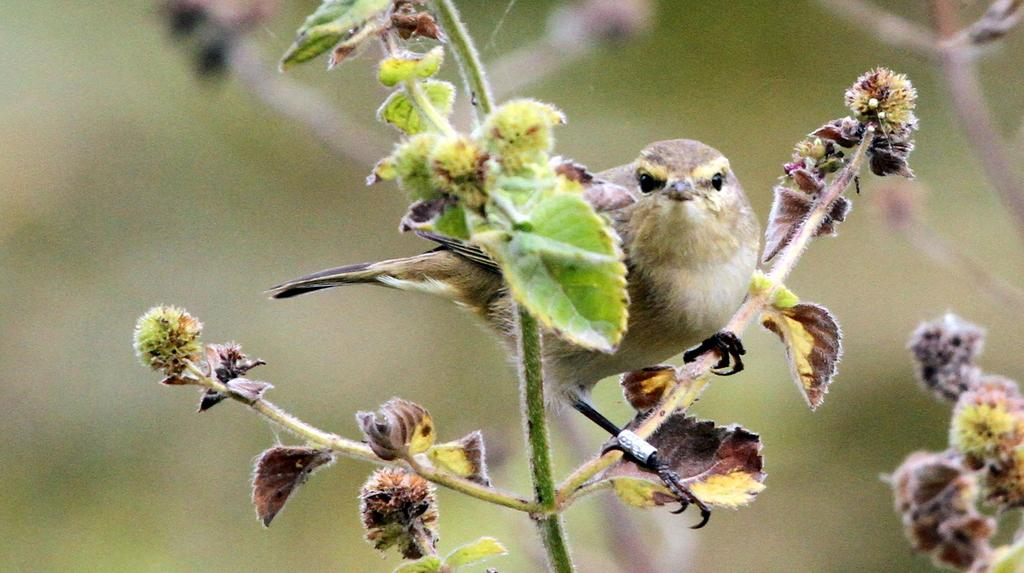What type of bird is in the image? There is a sparrow in the image. Where is the sparrow located in the image? The sparrow is sitting on the stem of a plant. How many sparrows are in the group that is crossing the bridge in the image? There is no group of sparrows crossing a bridge in the image; it only features a single sparrow sitting on a plant stem. 